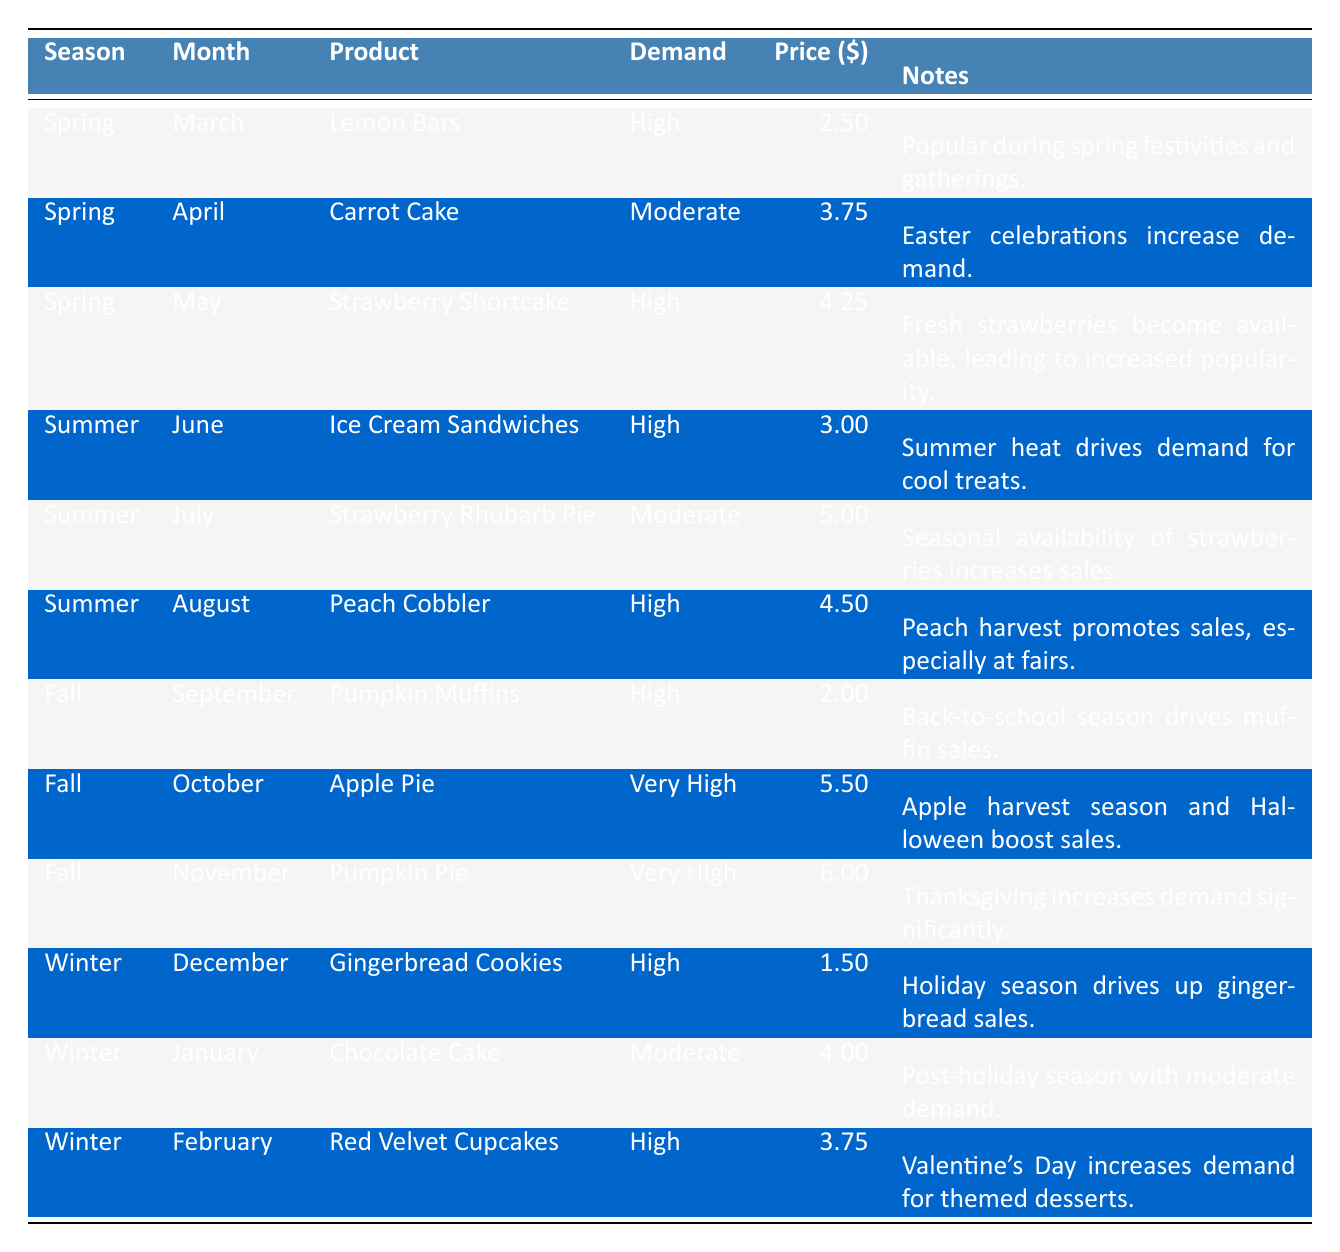What is the price of Pumpkin Pie? The table shows that for the month of November under the season Fall, the product Pumpkin Pie has a price listed as $6.00.
Answer: 6.00 Which product has the highest demand in the winter season? The table indicates that during winter (December, January, February), the products with high demand are Gingerbread Cookies, Chocolate Cake, and Red Velvet Cupcakes. Among these, only Red Velvet Cupcakes is noted as high demand in February, while Gingerbread Cookies has high demand in December. Taking these into account, the highest demand product in winter is Red Velvet Cupcakes.
Answer: Red Velvet Cupcakes What are the prices of all high-demand products in Spring? In Spring, Lemon Bars are $2.50 and Strawberry Shortcake is $4.25. Summing these prices gives $2.50 + $4.25 = $6.75 for high-demand products in Spring.
Answer: 6.75 Is there a product that has very high demand in the summer? Scanning the table for summer season products, I see that Ice Cream Sandwiches, Strawberry Rhubarb Pie, and Peach Cobbler are listed. However, none of these products are noted as very high demand; they are all at high or moderate levels. Therefore, the answer is no.
Answer: No What is the correlation between season and product price for high-demand items? For this question, we consider only the products with high demand across the seasons. In Spring, we have Lemon Bars ($2.50) and Strawberry Shortcake ($4.25). In Summer, Ice Cream Sandwiches ($3.00) and Peach Cobbler ($4.50) are included. In Fall, we have Pumpkin Muffins ($2.00), and in Winter, Red Velvet Cupcakes ($3.75) is noted. Analyzing these prices: Spring - $3.38 average, Summer - $3.75 average, Fall - $4.00 average, Winter - $3.75 average. There's an increasing trend though varying numbers, leading to no definitive correlation.
Answer: Varies What is the least expensive high-demand product listed in the table? Referring through the table, I find that the least expensive high-demand product is Pumpkin Muffins in September, which is priced at $2.00.
Answer: $2.00 How do the prices of seasonal products average across all seasons for high-demand products? The prices of high-demand products are Lemon Bars ($2.50), Strawberry Shortcake ($4.25), Ice Cream Sandwiches ($3.00), Peach Cobbler ($4.50), Pumpkin Muffins ($2.00), Apple Pie ($5.50), Pumpkin Pie ($6.00), Gingerbread Cookies ($1.50), and Red Velvet Cupcakes ($3.75). Summing those gives $33.00; dividing by the 9 entries yields an average of $3.67.
Answer: $3.67 During which month are both Pumpkin products in very high demand? According to the table, both the Pumpkin Pie in November and Pumpkin Muffins in September have very high demand. Following this, only November mentions both types of Pumpkin products with very high demand, focusing solely on Pumpkin Pie then.
Answer: November 